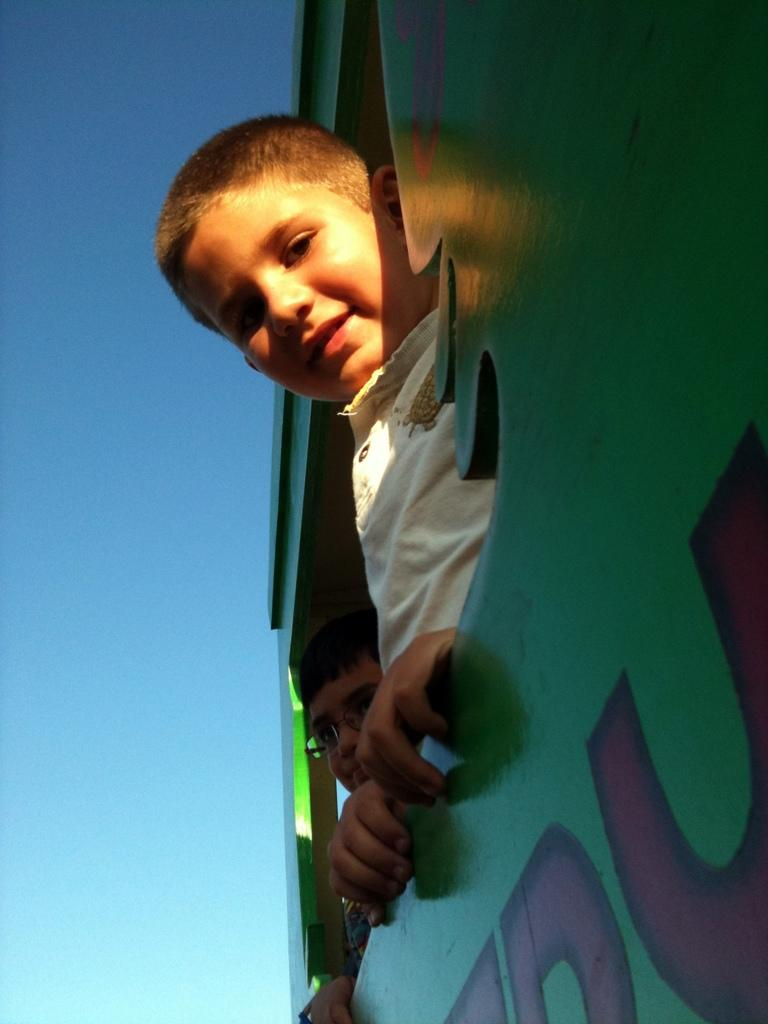Who is present in the image? There are boys in the image. What can be seen on a board in the image? There is text on a board in the image. What is visible in the background of the image? The sky is visible in the background of the image. What type of songs can be heard coming from the seashore in the image? There is no seashore present in the image, so it's not possible to determine what, if any, songs might be heard. 